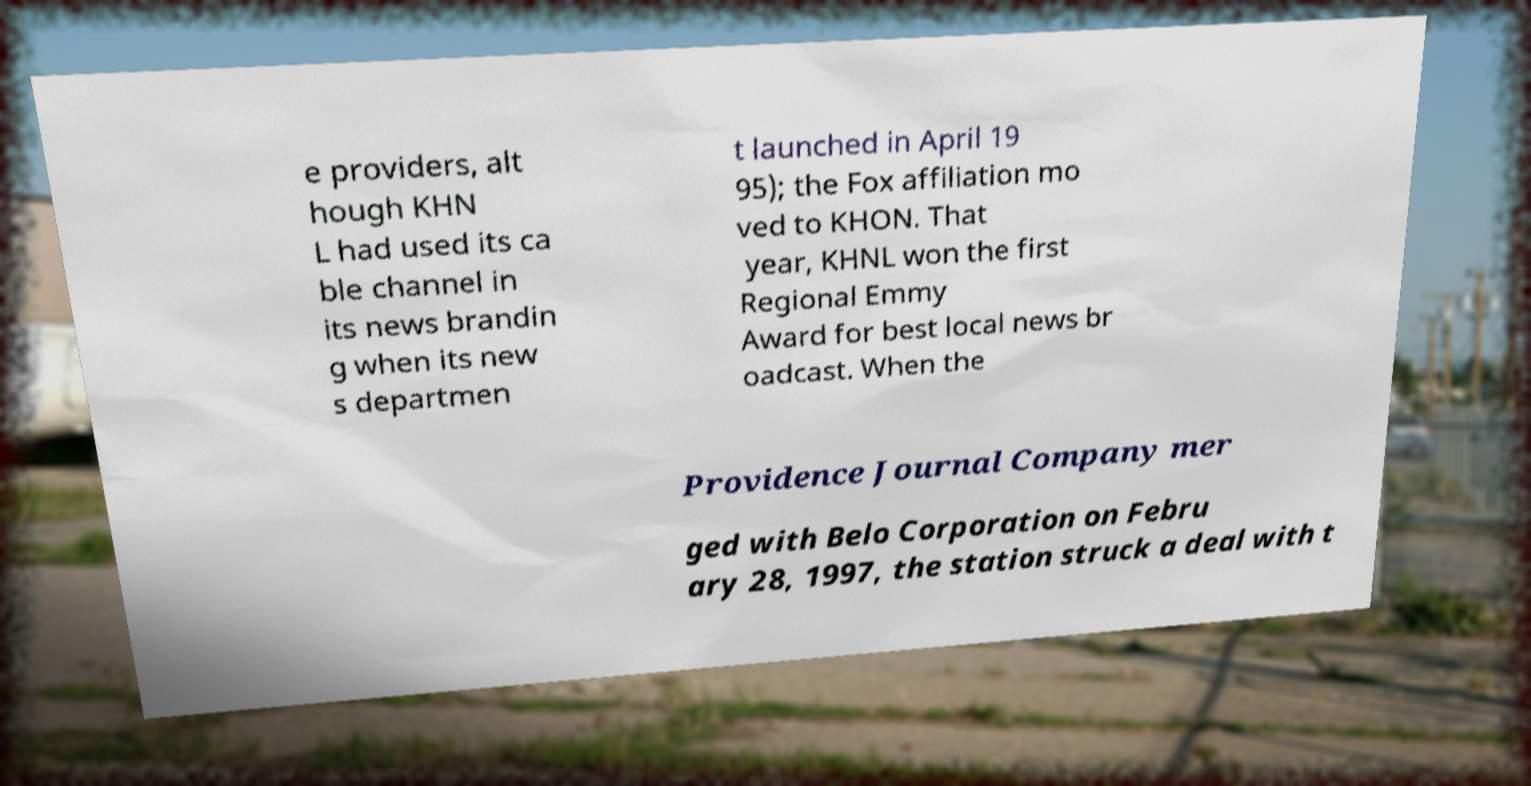Please identify and transcribe the text found in this image. e providers, alt hough KHN L had used its ca ble channel in its news brandin g when its new s departmen t launched in April 19 95); the Fox affiliation mo ved to KHON. That year, KHNL won the first Regional Emmy Award for best local news br oadcast. When the Providence Journal Company mer ged with Belo Corporation on Febru ary 28, 1997, the station struck a deal with t 